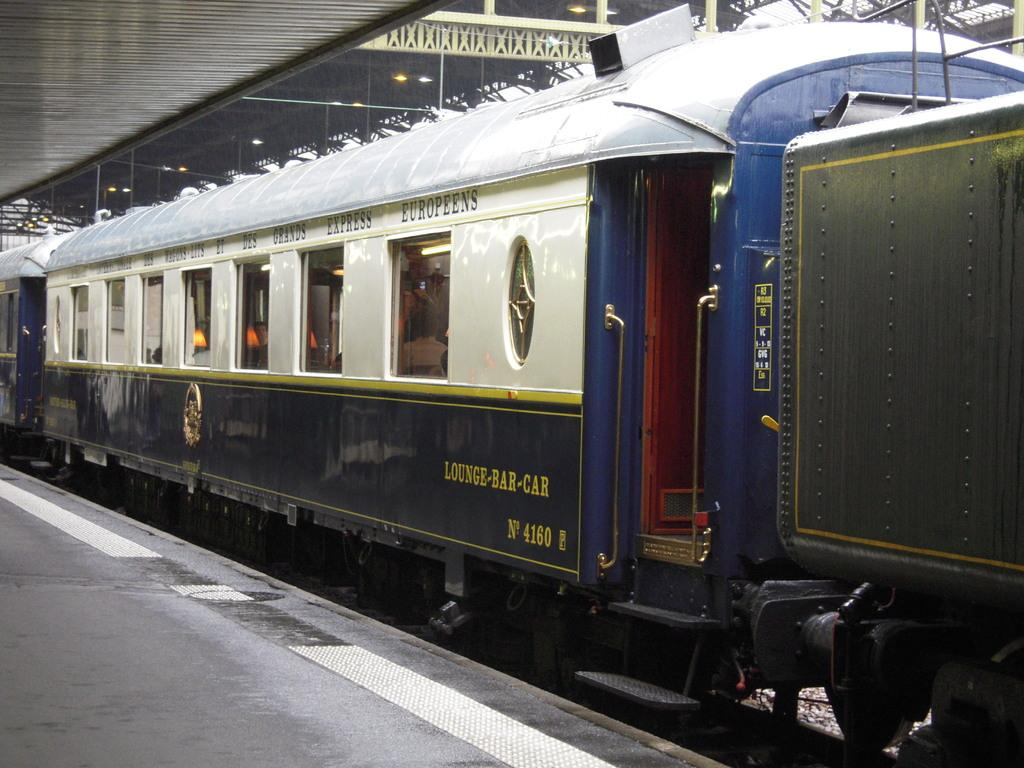<image>
Share a concise interpretation of the image provided. The lounge-bar car of a train sitting in a station. 